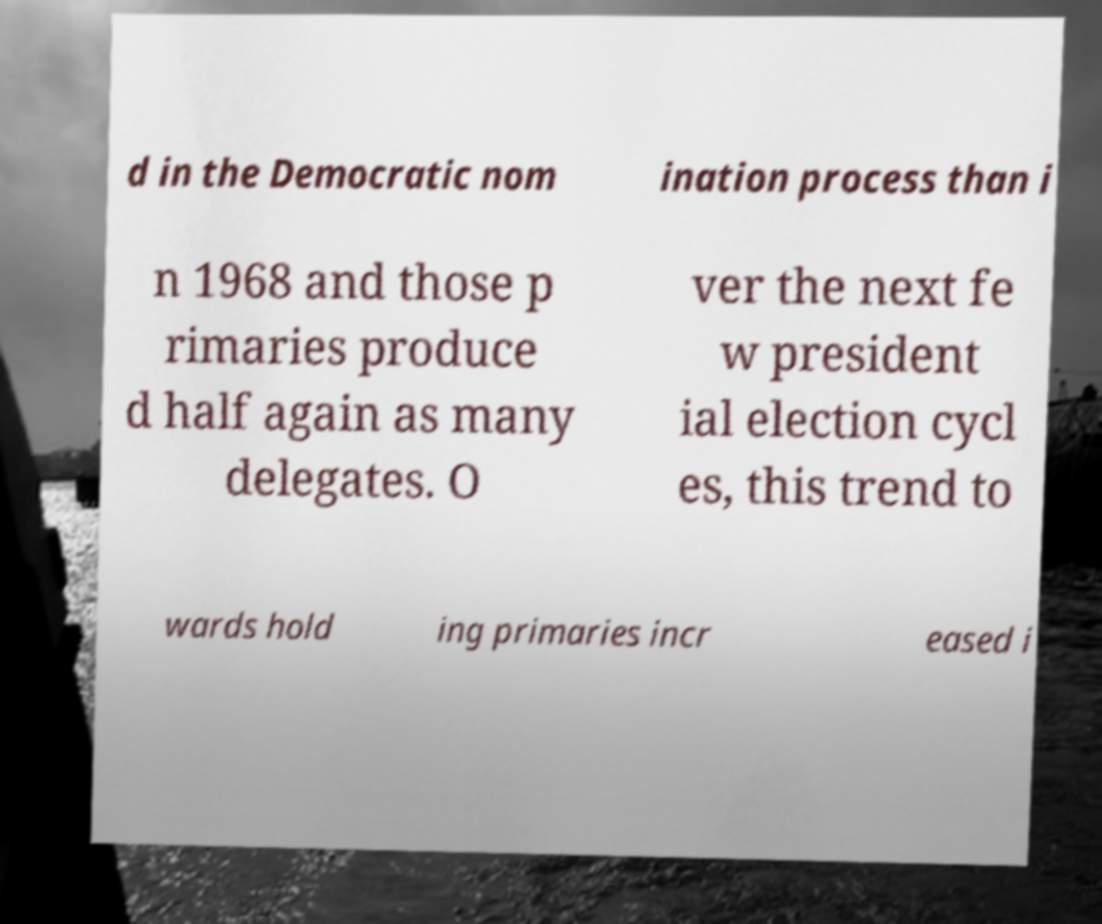Can you accurately transcribe the text from the provided image for me? d in the Democratic nom ination process than i n 1968 and those p rimaries produce d half again as many delegates. O ver the next fe w president ial election cycl es, this trend to wards hold ing primaries incr eased i 